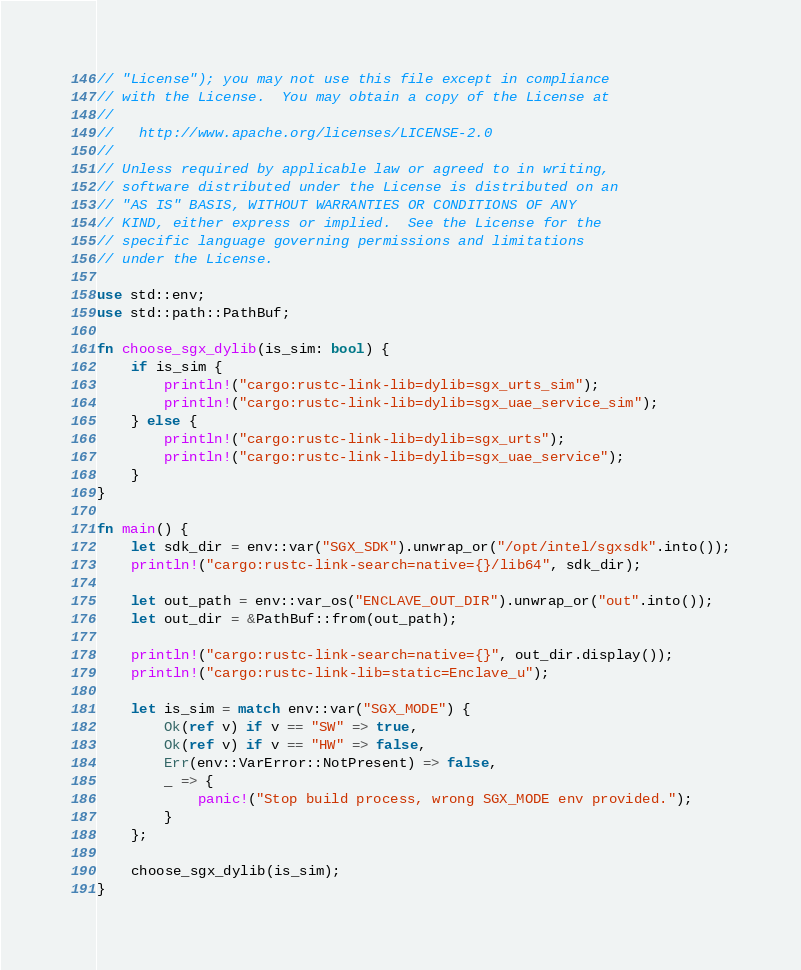Convert code to text. <code><loc_0><loc_0><loc_500><loc_500><_Rust_>// "License"); you may not use this file except in compliance
// with the License.  You may obtain a copy of the License at
//
//   http://www.apache.org/licenses/LICENSE-2.0
//
// Unless required by applicable law or agreed to in writing,
// software distributed under the License is distributed on an
// "AS IS" BASIS, WITHOUT WARRANTIES OR CONDITIONS OF ANY
// KIND, either express or implied.  See the License for the
// specific language governing permissions and limitations
// under the License.

use std::env;
use std::path::PathBuf;

fn choose_sgx_dylib(is_sim: bool) {
    if is_sim {
        println!("cargo:rustc-link-lib=dylib=sgx_urts_sim");
        println!("cargo:rustc-link-lib=dylib=sgx_uae_service_sim");
    } else {
        println!("cargo:rustc-link-lib=dylib=sgx_urts");
        println!("cargo:rustc-link-lib=dylib=sgx_uae_service");
    }
}

fn main() {
    let sdk_dir = env::var("SGX_SDK").unwrap_or("/opt/intel/sgxsdk".into());
    println!("cargo:rustc-link-search=native={}/lib64", sdk_dir);

    let out_path = env::var_os("ENCLAVE_OUT_DIR").unwrap_or("out".into());
    let out_dir = &PathBuf::from(out_path);

    println!("cargo:rustc-link-search=native={}", out_dir.display());
    println!("cargo:rustc-link-lib=static=Enclave_u");

    let is_sim = match env::var("SGX_MODE") {
        Ok(ref v) if v == "SW" => true,
        Ok(ref v) if v == "HW" => false,
        Err(env::VarError::NotPresent) => false,
        _ => {
            panic!("Stop build process, wrong SGX_MODE env provided.");
        }
    };

    choose_sgx_dylib(is_sim);
}
</code> 